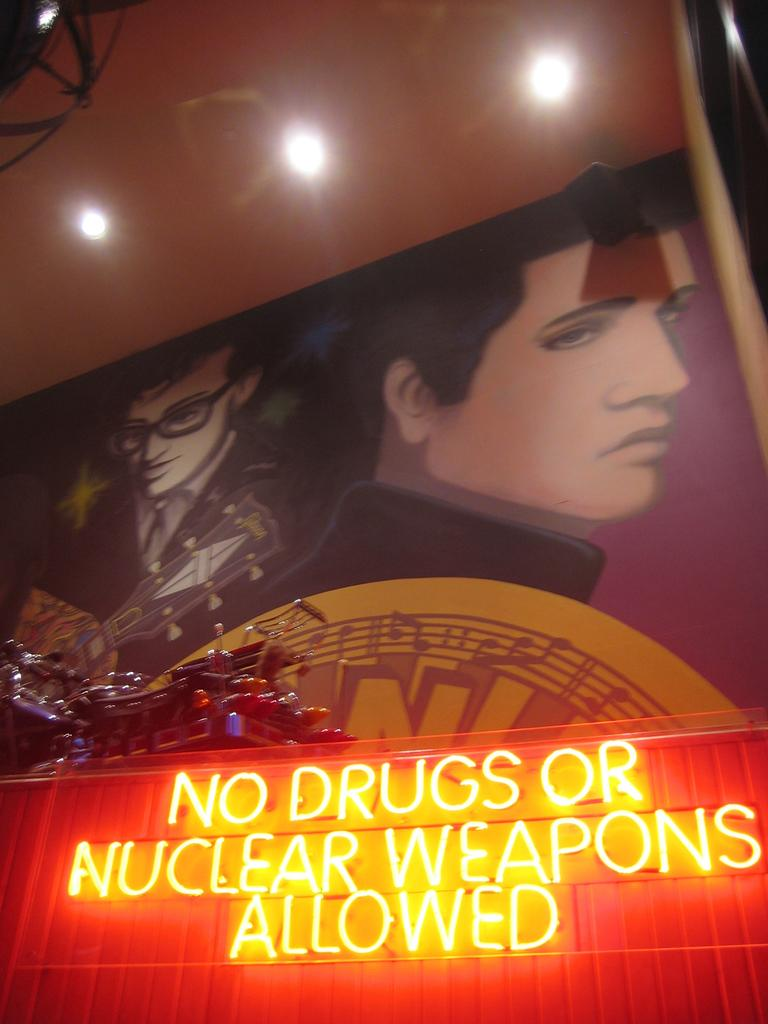<image>
Relay a brief, clear account of the picture shown. A sign that says No drugs or nuclear weapons allowed. 